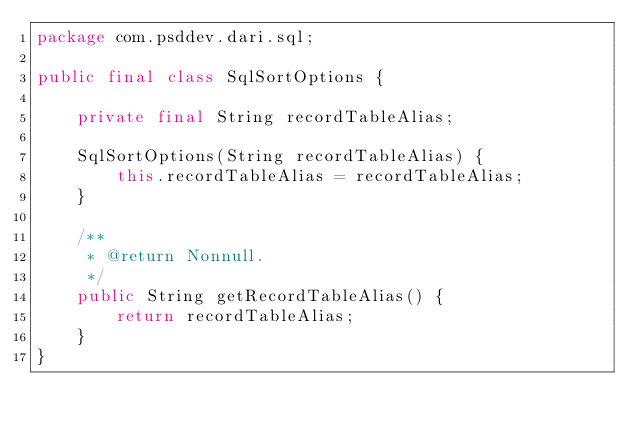Convert code to text. <code><loc_0><loc_0><loc_500><loc_500><_Java_>package com.psddev.dari.sql;

public final class SqlSortOptions {

    private final String recordTableAlias;

    SqlSortOptions(String recordTableAlias) {
        this.recordTableAlias = recordTableAlias;
    }

    /**
     * @return Nonnull.
     */
    public String getRecordTableAlias() {
        return recordTableAlias;
    }
}
</code> 